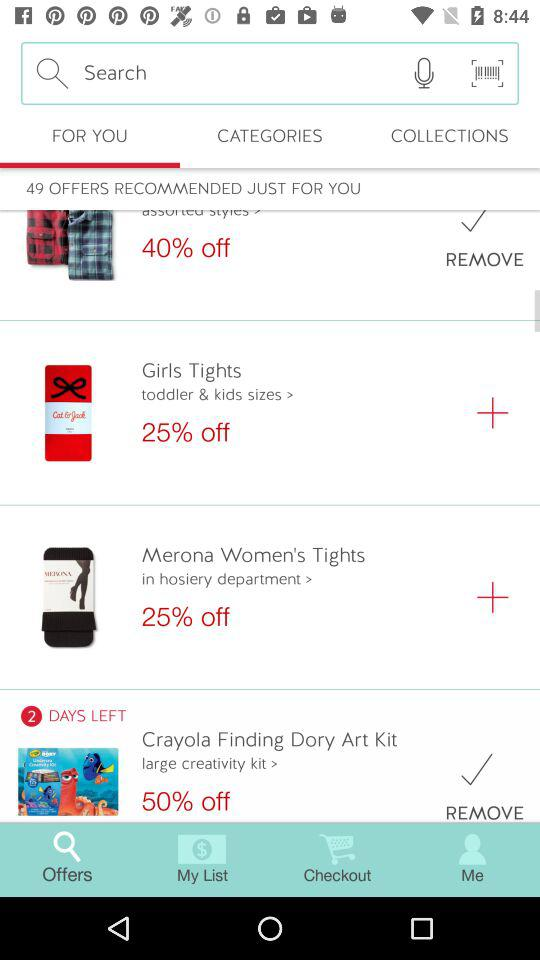How many offers are recommended just for you? There are 49 offers recommended. 